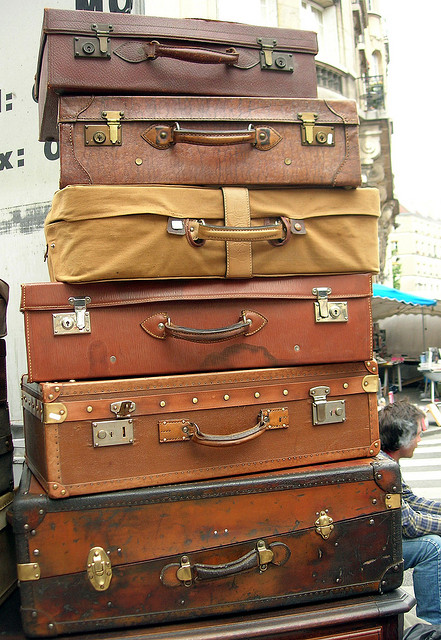What is the building at the back? It appears there has been a misunderstanding since the visible objects in the image are a stack of suitcases and there is no building discernible in the background. 